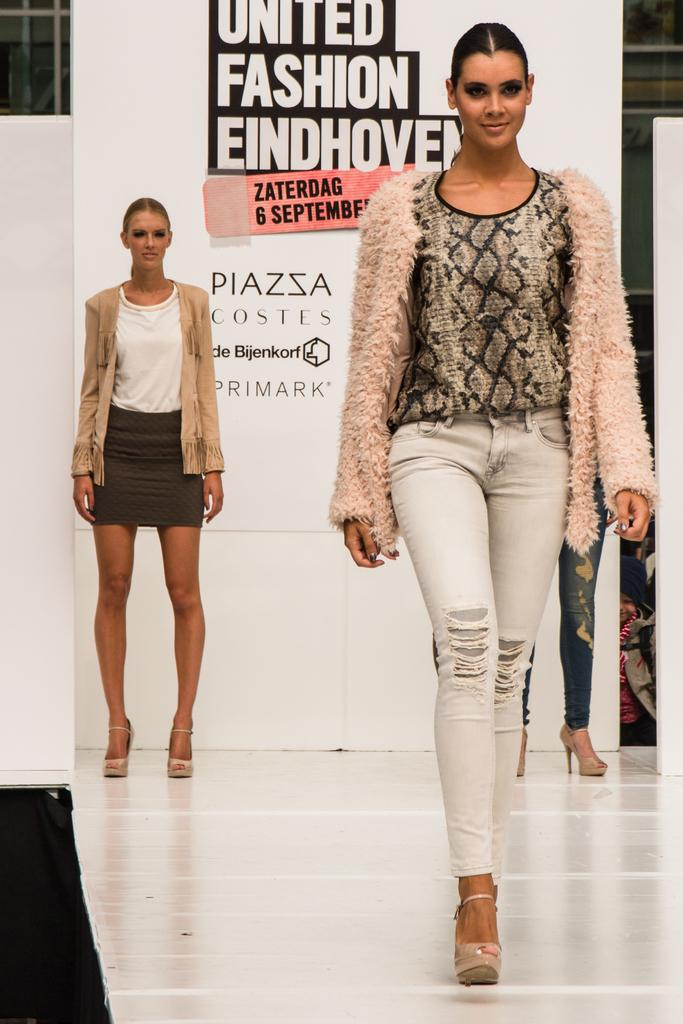How many people are in the image? There is a group of persons standing in the image. Can you describe the clothing of one of the individuals? One woman is wearing a brown coat. What can be seen in the background of the image? There is a poster with text in the background of the image. What type of stew is being served at the quiet history event in the image? There is no mention of a stew or a quiet history event in the image; it simply features a group of persons standing with a poster in the background. 